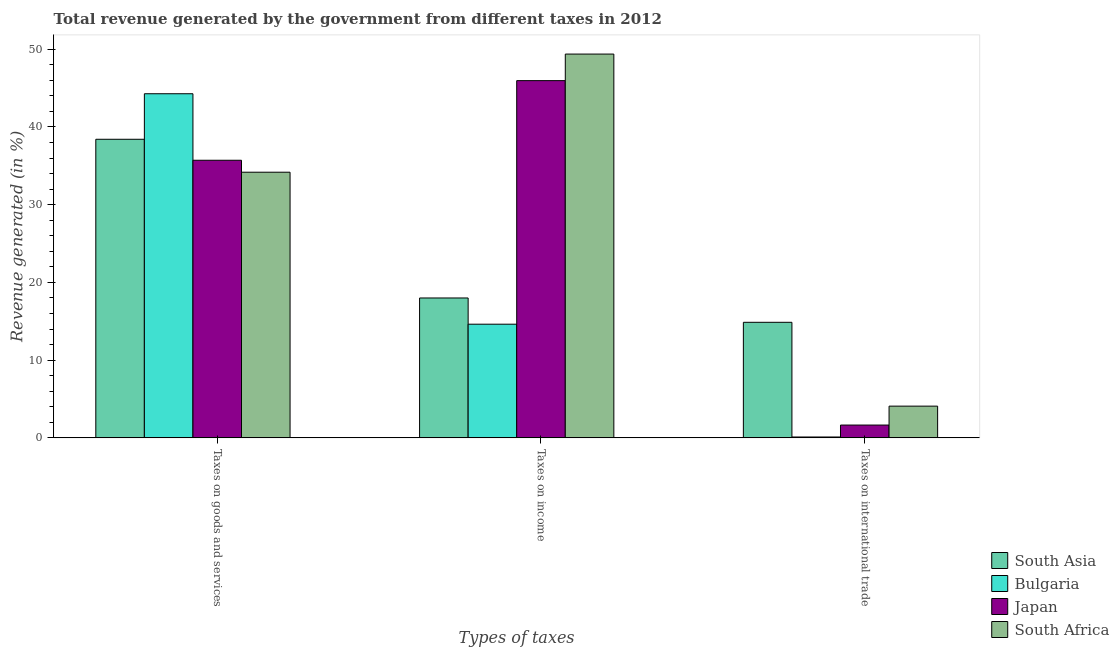Are the number of bars per tick equal to the number of legend labels?
Make the answer very short. Yes. Are the number of bars on each tick of the X-axis equal?
Keep it short and to the point. Yes. What is the label of the 1st group of bars from the left?
Offer a terse response. Taxes on goods and services. What is the percentage of revenue generated by taxes on goods and services in Bulgaria?
Provide a succinct answer. 44.27. Across all countries, what is the maximum percentage of revenue generated by taxes on income?
Provide a succinct answer. 49.38. Across all countries, what is the minimum percentage of revenue generated by taxes on goods and services?
Offer a terse response. 34.18. In which country was the percentage of revenue generated by taxes on goods and services minimum?
Give a very brief answer. South Africa. What is the total percentage of revenue generated by taxes on goods and services in the graph?
Your response must be concise. 152.57. What is the difference between the percentage of revenue generated by taxes on income in Bulgaria and that in Japan?
Offer a terse response. -31.33. What is the difference between the percentage of revenue generated by taxes on income in Japan and the percentage of revenue generated by taxes on goods and services in South Asia?
Offer a terse response. 7.54. What is the average percentage of revenue generated by taxes on income per country?
Offer a terse response. 31.99. What is the difference between the percentage of revenue generated by taxes on goods and services and percentage of revenue generated by taxes on income in Bulgaria?
Your answer should be very brief. 29.65. What is the ratio of the percentage of revenue generated by taxes on goods and services in Japan to that in South Asia?
Ensure brevity in your answer.  0.93. Is the difference between the percentage of revenue generated by taxes on income in South Africa and Japan greater than the difference between the percentage of revenue generated by taxes on goods and services in South Africa and Japan?
Keep it short and to the point. Yes. What is the difference between the highest and the second highest percentage of revenue generated by tax on international trade?
Your response must be concise. 10.78. What is the difference between the highest and the lowest percentage of revenue generated by tax on international trade?
Offer a terse response. 14.75. In how many countries, is the percentage of revenue generated by taxes on income greater than the average percentage of revenue generated by taxes on income taken over all countries?
Provide a succinct answer. 2. Is the sum of the percentage of revenue generated by taxes on income in Japan and Bulgaria greater than the maximum percentage of revenue generated by taxes on goods and services across all countries?
Keep it short and to the point. Yes. What does the 3rd bar from the left in Taxes on goods and services represents?
Provide a succinct answer. Japan. What does the 2nd bar from the right in Taxes on international trade represents?
Make the answer very short. Japan. Is it the case that in every country, the sum of the percentage of revenue generated by taxes on goods and services and percentage of revenue generated by taxes on income is greater than the percentage of revenue generated by tax on international trade?
Provide a short and direct response. Yes. Are all the bars in the graph horizontal?
Your answer should be compact. No. Are the values on the major ticks of Y-axis written in scientific E-notation?
Offer a very short reply. No. Does the graph contain grids?
Provide a short and direct response. No. What is the title of the graph?
Your response must be concise. Total revenue generated by the government from different taxes in 2012. Does "Oman" appear as one of the legend labels in the graph?
Your response must be concise. No. What is the label or title of the X-axis?
Keep it short and to the point. Types of taxes. What is the label or title of the Y-axis?
Your response must be concise. Revenue generated (in %). What is the Revenue generated (in %) in South Asia in Taxes on goods and services?
Keep it short and to the point. 38.41. What is the Revenue generated (in %) of Bulgaria in Taxes on goods and services?
Give a very brief answer. 44.27. What is the Revenue generated (in %) in Japan in Taxes on goods and services?
Your response must be concise. 35.71. What is the Revenue generated (in %) in South Africa in Taxes on goods and services?
Offer a terse response. 34.18. What is the Revenue generated (in %) in South Asia in Taxes on income?
Make the answer very short. 18. What is the Revenue generated (in %) in Bulgaria in Taxes on income?
Your answer should be very brief. 14.62. What is the Revenue generated (in %) of Japan in Taxes on income?
Provide a succinct answer. 45.96. What is the Revenue generated (in %) in South Africa in Taxes on income?
Provide a short and direct response. 49.38. What is the Revenue generated (in %) in South Asia in Taxes on international trade?
Your response must be concise. 14.87. What is the Revenue generated (in %) of Bulgaria in Taxes on international trade?
Offer a very short reply. 0.11. What is the Revenue generated (in %) in Japan in Taxes on international trade?
Provide a succinct answer. 1.65. What is the Revenue generated (in %) of South Africa in Taxes on international trade?
Make the answer very short. 4.08. Across all Types of taxes, what is the maximum Revenue generated (in %) of South Asia?
Give a very brief answer. 38.41. Across all Types of taxes, what is the maximum Revenue generated (in %) in Bulgaria?
Offer a very short reply. 44.27. Across all Types of taxes, what is the maximum Revenue generated (in %) in Japan?
Offer a very short reply. 45.96. Across all Types of taxes, what is the maximum Revenue generated (in %) of South Africa?
Provide a short and direct response. 49.38. Across all Types of taxes, what is the minimum Revenue generated (in %) in South Asia?
Offer a terse response. 14.87. Across all Types of taxes, what is the minimum Revenue generated (in %) in Bulgaria?
Keep it short and to the point. 0.11. Across all Types of taxes, what is the minimum Revenue generated (in %) of Japan?
Provide a short and direct response. 1.65. Across all Types of taxes, what is the minimum Revenue generated (in %) of South Africa?
Ensure brevity in your answer.  4.08. What is the total Revenue generated (in %) in South Asia in the graph?
Your answer should be very brief. 71.28. What is the total Revenue generated (in %) in Bulgaria in the graph?
Ensure brevity in your answer.  59.01. What is the total Revenue generated (in %) in Japan in the graph?
Ensure brevity in your answer.  83.32. What is the total Revenue generated (in %) of South Africa in the graph?
Make the answer very short. 87.63. What is the difference between the Revenue generated (in %) of South Asia in Taxes on goods and services and that in Taxes on income?
Offer a terse response. 20.42. What is the difference between the Revenue generated (in %) in Bulgaria in Taxes on goods and services and that in Taxes on income?
Ensure brevity in your answer.  29.65. What is the difference between the Revenue generated (in %) in Japan in Taxes on goods and services and that in Taxes on income?
Ensure brevity in your answer.  -10.25. What is the difference between the Revenue generated (in %) in South Africa in Taxes on goods and services and that in Taxes on income?
Offer a terse response. -15.2. What is the difference between the Revenue generated (in %) in South Asia in Taxes on goods and services and that in Taxes on international trade?
Give a very brief answer. 23.55. What is the difference between the Revenue generated (in %) in Bulgaria in Taxes on goods and services and that in Taxes on international trade?
Offer a very short reply. 44.16. What is the difference between the Revenue generated (in %) in Japan in Taxes on goods and services and that in Taxes on international trade?
Provide a succinct answer. 34.06. What is the difference between the Revenue generated (in %) of South Africa in Taxes on goods and services and that in Taxes on international trade?
Provide a succinct answer. 30.09. What is the difference between the Revenue generated (in %) in South Asia in Taxes on income and that in Taxes on international trade?
Your response must be concise. 3.13. What is the difference between the Revenue generated (in %) of Bulgaria in Taxes on income and that in Taxes on international trade?
Offer a terse response. 14.51. What is the difference between the Revenue generated (in %) of Japan in Taxes on income and that in Taxes on international trade?
Provide a short and direct response. 44.31. What is the difference between the Revenue generated (in %) in South Africa in Taxes on income and that in Taxes on international trade?
Make the answer very short. 45.29. What is the difference between the Revenue generated (in %) of South Asia in Taxes on goods and services and the Revenue generated (in %) of Bulgaria in Taxes on income?
Offer a very short reply. 23.79. What is the difference between the Revenue generated (in %) of South Asia in Taxes on goods and services and the Revenue generated (in %) of Japan in Taxes on income?
Give a very brief answer. -7.54. What is the difference between the Revenue generated (in %) in South Asia in Taxes on goods and services and the Revenue generated (in %) in South Africa in Taxes on income?
Offer a very short reply. -10.96. What is the difference between the Revenue generated (in %) in Bulgaria in Taxes on goods and services and the Revenue generated (in %) in Japan in Taxes on income?
Make the answer very short. -1.69. What is the difference between the Revenue generated (in %) in Bulgaria in Taxes on goods and services and the Revenue generated (in %) in South Africa in Taxes on income?
Provide a succinct answer. -5.1. What is the difference between the Revenue generated (in %) in Japan in Taxes on goods and services and the Revenue generated (in %) in South Africa in Taxes on income?
Ensure brevity in your answer.  -13.66. What is the difference between the Revenue generated (in %) in South Asia in Taxes on goods and services and the Revenue generated (in %) in Bulgaria in Taxes on international trade?
Ensure brevity in your answer.  38.3. What is the difference between the Revenue generated (in %) in South Asia in Taxes on goods and services and the Revenue generated (in %) in Japan in Taxes on international trade?
Your answer should be very brief. 36.77. What is the difference between the Revenue generated (in %) in South Asia in Taxes on goods and services and the Revenue generated (in %) in South Africa in Taxes on international trade?
Your answer should be compact. 34.33. What is the difference between the Revenue generated (in %) in Bulgaria in Taxes on goods and services and the Revenue generated (in %) in Japan in Taxes on international trade?
Keep it short and to the point. 42.62. What is the difference between the Revenue generated (in %) in Bulgaria in Taxes on goods and services and the Revenue generated (in %) in South Africa in Taxes on international trade?
Your answer should be very brief. 40.19. What is the difference between the Revenue generated (in %) in Japan in Taxes on goods and services and the Revenue generated (in %) in South Africa in Taxes on international trade?
Give a very brief answer. 31.63. What is the difference between the Revenue generated (in %) of South Asia in Taxes on income and the Revenue generated (in %) of Bulgaria in Taxes on international trade?
Offer a terse response. 17.88. What is the difference between the Revenue generated (in %) in South Asia in Taxes on income and the Revenue generated (in %) in Japan in Taxes on international trade?
Provide a succinct answer. 16.35. What is the difference between the Revenue generated (in %) in South Asia in Taxes on income and the Revenue generated (in %) in South Africa in Taxes on international trade?
Provide a succinct answer. 13.91. What is the difference between the Revenue generated (in %) in Bulgaria in Taxes on income and the Revenue generated (in %) in Japan in Taxes on international trade?
Your answer should be very brief. 12.98. What is the difference between the Revenue generated (in %) of Bulgaria in Taxes on income and the Revenue generated (in %) of South Africa in Taxes on international trade?
Offer a very short reply. 10.54. What is the difference between the Revenue generated (in %) of Japan in Taxes on income and the Revenue generated (in %) of South Africa in Taxes on international trade?
Provide a succinct answer. 41.88. What is the average Revenue generated (in %) of South Asia per Types of taxes?
Your answer should be very brief. 23.76. What is the average Revenue generated (in %) in Bulgaria per Types of taxes?
Your answer should be very brief. 19.67. What is the average Revenue generated (in %) in Japan per Types of taxes?
Ensure brevity in your answer.  27.77. What is the average Revenue generated (in %) of South Africa per Types of taxes?
Provide a succinct answer. 29.21. What is the difference between the Revenue generated (in %) of South Asia and Revenue generated (in %) of Bulgaria in Taxes on goods and services?
Give a very brief answer. -5.86. What is the difference between the Revenue generated (in %) in South Asia and Revenue generated (in %) in Japan in Taxes on goods and services?
Your answer should be compact. 2.7. What is the difference between the Revenue generated (in %) of South Asia and Revenue generated (in %) of South Africa in Taxes on goods and services?
Give a very brief answer. 4.24. What is the difference between the Revenue generated (in %) in Bulgaria and Revenue generated (in %) in Japan in Taxes on goods and services?
Provide a short and direct response. 8.56. What is the difference between the Revenue generated (in %) in Bulgaria and Revenue generated (in %) in South Africa in Taxes on goods and services?
Ensure brevity in your answer.  10.09. What is the difference between the Revenue generated (in %) of Japan and Revenue generated (in %) of South Africa in Taxes on goods and services?
Provide a short and direct response. 1.54. What is the difference between the Revenue generated (in %) in South Asia and Revenue generated (in %) in Bulgaria in Taxes on income?
Keep it short and to the point. 3.37. What is the difference between the Revenue generated (in %) in South Asia and Revenue generated (in %) in Japan in Taxes on income?
Your answer should be compact. -27.96. What is the difference between the Revenue generated (in %) of South Asia and Revenue generated (in %) of South Africa in Taxes on income?
Provide a succinct answer. -31.38. What is the difference between the Revenue generated (in %) in Bulgaria and Revenue generated (in %) in Japan in Taxes on income?
Ensure brevity in your answer.  -31.33. What is the difference between the Revenue generated (in %) in Bulgaria and Revenue generated (in %) in South Africa in Taxes on income?
Offer a terse response. -34.75. What is the difference between the Revenue generated (in %) in Japan and Revenue generated (in %) in South Africa in Taxes on income?
Provide a short and direct response. -3.42. What is the difference between the Revenue generated (in %) in South Asia and Revenue generated (in %) in Bulgaria in Taxes on international trade?
Provide a succinct answer. 14.75. What is the difference between the Revenue generated (in %) of South Asia and Revenue generated (in %) of Japan in Taxes on international trade?
Provide a short and direct response. 13.22. What is the difference between the Revenue generated (in %) of South Asia and Revenue generated (in %) of South Africa in Taxes on international trade?
Make the answer very short. 10.78. What is the difference between the Revenue generated (in %) of Bulgaria and Revenue generated (in %) of Japan in Taxes on international trade?
Your response must be concise. -1.54. What is the difference between the Revenue generated (in %) of Bulgaria and Revenue generated (in %) of South Africa in Taxes on international trade?
Offer a terse response. -3.97. What is the difference between the Revenue generated (in %) in Japan and Revenue generated (in %) in South Africa in Taxes on international trade?
Give a very brief answer. -2.43. What is the ratio of the Revenue generated (in %) of South Asia in Taxes on goods and services to that in Taxes on income?
Offer a terse response. 2.13. What is the ratio of the Revenue generated (in %) of Bulgaria in Taxes on goods and services to that in Taxes on income?
Offer a very short reply. 3.03. What is the ratio of the Revenue generated (in %) in Japan in Taxes on goods and services to that in Taxes on income?
Your answer should be very brief. 0.78. What is the ratio of the Revenue generated (in %) in South Africa in Taxes on goods and services to that in Taxes on income?
Ensure brevity in your answer.  0.69. What is the ratio of the Revenue generated (in %) in South Asia in Taxes on goods and services to that in Taxes on international trade?
Make the answer very short. 2.58. What is the ratio of the Revenue generated (in %) of Bulgaria in Taxes on goods and services to that in Taxes on international trade?
Make the answer very short. 393.5. What is the ratio of the Revenue generated (in %) of Japan in Taxes on goods and services to that in Taxes on international trade?
Provide a succinct answer. 21.66. What is the ratio of the Revenue generated (in %) in South Africa in Taxes on goods and services to that in Taxes on international trade?
Give a very brief answer. 8.37. What is the ratio of the Revenue generated (in %) in South Asia in Taxes on income to that in Taxes on international trade?
Your answer should be very brief. 1.21. What is the ratio of the Revenue generated (in %) in Bulgaria in Taxes on income to that in Taxes on international trade?
Provide a succinct answer. 129.98. What is the ratio of the Revenue generated (in %) of Japan in Taxes on income to that in Taxes on international trade?
Your response must be concise. 27.88. What is the ratio of the Revenue generated (in %) in South Africa in Taxes on income to that in Taxes on international trade?
Provide a succinct answer. 12.1. What is the difference between the highest and the second highest Revenue generated (in %) in South Asia?
Your answer should be very brief. 20.42. What is the difference between the highest and the second highest Revenue generated (in %) in Bulgaria?
Your answer should be very brief. 29.65. What is the difference between the highest and the second highest Revenue generated (in %) in Japan?
Ensure brevity in your answer.  10.25. What is the difference between the highest and the second highest Revenue generated (in %) of South Africa?
Keep it short and to the point. 15.2. What is the difference between the highest and the lowest Revenue generated (in %) in South Asia?
Your answer should be very brief. 23.55. What is the difference between the highest and the lowest Revenue generated (in %) of Bulgaria?
Offer a very short reply. 44.16. What is the difference between the highest and the lowest Revenue generated (in %) in Japan?
Your answer should be very brief. 44.31. What is the difference between the highest and the lowest Revenue generated (in %) of South Africa?
Provide a succinct answer. 45.29. 